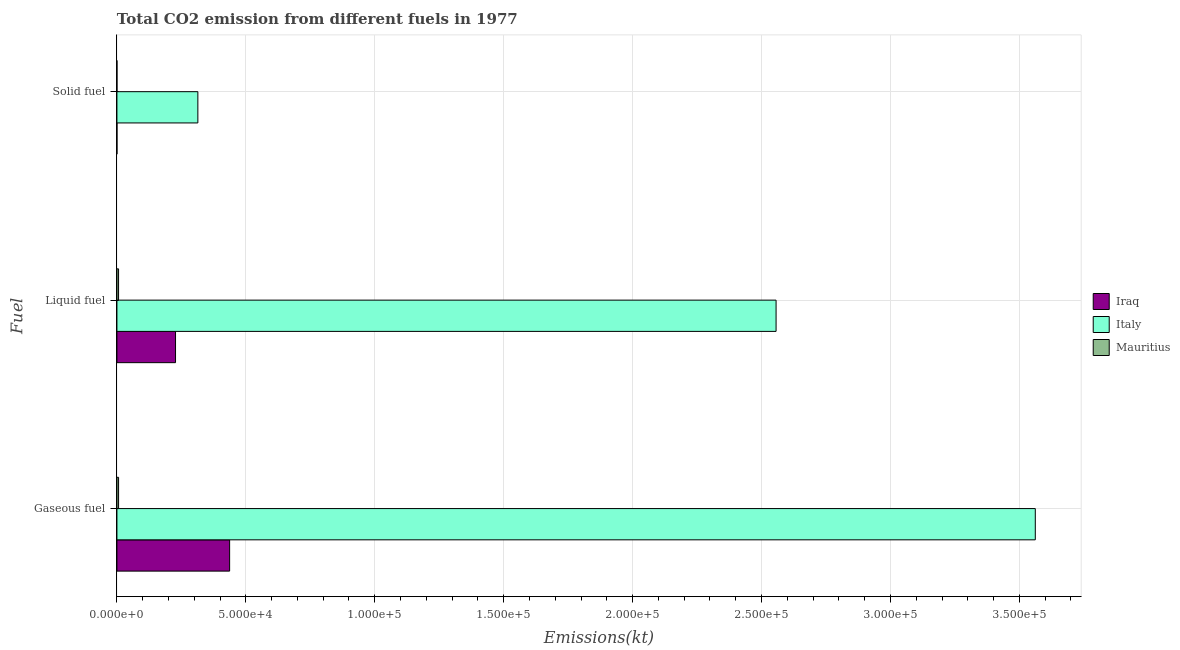Are the number of bars per tick equal to the number of legend labels?
Make the answer very short. Yes. What is the label of the 2nd group of bars from the top?
Give a very brief answer. Liquid fuel. What is the amount of co2 emissions from gaseous fuel in Italy?
Offer a terse response. 3.56e+05. Across all countries, what is the maximum amount of co2 emissions from gaseous fuel?
Ensure brevity in your answer.  3.56e+05. Across all countries, what is the minimum amount of co2 emissions from solid fuel?
Keep it short and to the point. 3.67. In which country was the amount of co2 emissions from solid fuel minimum?
Your answer should be very brief. Iraq. What is the total amount of co2 emissions from liquid fuel in the graph?
Provide a succinct answer. 2.79e+05. What is the difference between the amount of co2 emissions from liquid fuel in Mauritius and that in Italy?
Make the answer very short. -2.55e+05. What is the difference between the amount of co2 emissions from gaseous fuel in Iraq and the amount of co2 emissions from solid fuel in Mauritius?
Your response must be concise. 4.37e+04. What is the average amount of co2 emissions from liquid fuel per country?
Make the answer very short. 9.30e+04. What is the difference between the amount of co2 emissions from gaseous fuel and amount of co2 emissions from solid fuel in Mauritius?
Your answer should be compact. 638.06. In how many countries, is the amount of co2 emissions from liquid fuel greater than 130000 kt?
Make the answer very short. 1. What is the ratio of the amount of co2 emissions from liquid fuel in Italy to that in Iraq?
Provide a succinct answer. 11.25. Is the amount of co2 emissions from liquid fuel in Iraq less than that in Italy?
Offer a very short reply. Yes. Is the difference between the amount of co2 emissions from solid fuel in Italy and Mauritius greater than the difference between the amount of co2 emissions from gaseous fuel in Italy and Mauritius?
Your response must be concise. No. What is the difference between the highest and the second highest amount of co2 emissions from liquid fuel?
Offer a terse response. 2.33e+05. What is the difference between the highest and the lowest amount of co2 emissions from liquid fuel?
Give a very brief answer. 2.55e+05. Is the sum of the amount of co2 emissions from gaseous fuel in Mauritius and Iraq greater than the maximum amount of co2 emissions from liquid fuel across all countries?
Make the answer very short. No. What does the 3rd bar from the top in Solid fuel represents?
Make the answer very short. Iraq. What does the 3rd bar from the bottom in Gaseous fuel represents?
Offer a very short reply. Mauritius. Is it the case that in every country, the sum of the amount of co2 emissions from gaseous fuel and amount of co2 emissions from liquid fuel is greater than the amount of co2 emissions from solid fuel?
Your response must be concise. Yes. How many countries are there in the graph?
Offer a very short reply. 3. Are the values on the major ticks of X-axis written in scientific E-notation?
Offer a very short reply. Yes. Does the graph contain any zero values?
Keep it short and to the point. No. Does the graph contain grids?
Your answer should be compact. Yes. How many legend labels are there?
Offer a terse response. 3. What is the title of the graph?
Ensure brevity in your answer.  Total CO2 emission from different fuels in 1977. Does "Australia" appear as one of the legend labels in the graph?
Provide a succinct answer. No. What is the label or title of the X-axis?
Your response must be concise. Emissions(kt). What is the label or title of the Y-axis?
Make the answer very short. Fuel. What is the Emissions(kt) in Iraq in Gaseous fuel?
Ensure brevity in your answer.  4.37e+04. What is the Emissions(kt) of Italy in Gaseous fuel?
Provide a short and direct response. 3.56e+05. What is the Emissions(kt) of Mauritius in Gaseous fuel?
Keep it short and to the point. 641.73. What is the Emissions(kt) of Iraq in Liquid fuel?
Your answer should be very brief. 2.27e+04. What is the Emissions(kt) in Italy in Liquid fuel?
Keep it short and to the point. 2.56e+05. What is the Emissions(kt) in Mauritius in Liquid fuel?
Provide a succinct answer. 638.06. What is the Emissions(kt) in Iraq in Solid fuel?
Offer a very short reply. 3.67. What is the Emissions(kt) in Italy in Solid fuel?
Ensure brevity in your answer.  3.14e+04. What is the Emissions(kt) in Mauritius in Solid fuel?
Make the answer very short. 3.67. Across all Fuel, what is the maximum Emissions(kt) of Iraq?
Provide a succinct answer. 4.37e+04. Across all Fuel, what is the maximum Emissions(kt) of Italy?
Make the answer very short. 3.56e+05. Across all Fuel, what is the maximum Emissions(kt) of Mauritius?
Offer a very short reply. 641.73. Across all Fuel, what is the minimum Emissions(kt) in Iraq?
Your response must be concise. 3.67. Across all Fuel, what is the minimum Emissions(kt) of Italy?
Your answer should be compact. 3.14e+04. Across all Fuel, what is the minimum Emissions(kt) of Mauritius?
Keep it short and to the point. 3.67. What is the total Emissions(kt) of Iraq in the graph?
Provide a succinct answer. 6.64e+04. What is the total Emissions(kt) of Italy in the graph?
Provide a succinct answer. 6.43e+05. What is the total Emissions(kt) of Mauritius in the graph?
Your answer should be compact. 1283.45. What is the difference between the Emissions(kt) of Iraq in Gaseous fuel and that in Liquid fuel?
Provide a short and direct response. 2.10e+04. What is the difference between the Emissions(kt) of Italy in Gaseous fuel and that in Liquid fuel?
Your answer should be very brief. 1.01e+05. What is the difference between the Emissions(kt) of Mauritius in Gaseous fuel and that in Liquid fuel?
Your response must be concise. 3.67. What is the difference between the Emissions(kt) in Iraq in Gaseous fuel and that in Solid fuel?
Make the answer very short. 4.37e+04. What is the difference between the Emissions(kt) of Italy in Gaseous fuel and that in Solid fuel?
Your response must be concise. 3.25e+05. What is the difference between the Emissions(kt) of Mauritius in Gaseous fuel and that in Solid fuel?
Provide a short and direct response. 638.06. What is the difference between the Emissions(kt) in Iraq in Liquid fuel and that in Solid fuel?
Make the answer very short. 2.27e+04. What is the difference between the Emissions(kt) in Italy in Liquid fuel and that in Solid fuel?
Your answer should be compact. 2.24e+05. What is the difference between the Emissions(kt) in Mauritius in Liquid fuel and that in Solid fuel?
Ensure brevity in your answer.  634.39. What is the difference between the Emissions(kt) in Iraq in Gaseous fuel and the Emissions(kt) in Italy in Liquid fuel?
Offer a terse response. -2.12e+05. What is the difference between the Emissions(kt) in Iraq in Gaseous fuel and the Emissions(kt) in Mauritius in Liquid fuel?
Keep it short and to the point. 4.31e+04. What is the difference between the Emissions(kt) in Italy in Gaseous fuel and the Emissions(kt) in Mauritius in Liquid fuel?
Ensure brevity in your answer.  3.56e+05. What is the difference between the Emissions(kt) of Iraq in Gaseous fuel and the Emissions(kt) of Italy in Solid fuel?
Provide a short and direct response. 1.23e+04. What is the difference between the Emissions(kt) of Iraq in Gaseous fuel and the Emissions(kt) of Mauritius in Solid fuel?
Provide a short and direct response. 4.37e+04. What is the difference between the Emissions(kt) in Italy in Gaseous fuel and the Emissions(kt) in Mauritius in Solid fuel?
Your response must be concise. 3.56e+05. What is the difference between the Emissions(kt) in Iraq in Liquid fuel and the Emissions(kt) in Italy in Solid fuel?
Offer a very short reply. -8665.12. What is the difference between the Emissions(kt) in Iraq in Liquid fuel and the Emissions(kt) in Mauritius in Solid fuel?
Provide a short and direct response. 2.27e+04. What is the difference between the Emissions(kt) of Italy in Liquid fuel and the Emissions(kt) of Mauritius in Solid fuel?
Keep it short and to the point. 2.56e+05. What is the average Emissions(kt) of Iraq per Fuel?
Provide a short and direct response. 2.21e+04. What is the average Emissions(kt) in Italy per Fuel?
Your answer should be very brief. 2.14e+05. What is the average Emissions(kt) of Mauritius per Fuel?
Provide a succinct answer. 427.82. What is the difference between the Emissions(kt) in Iraq and Emissions(kt) in Italy in Gaseous fuel?
Offer a very short reply. -3.12e+05. What is the difference between the Emissions(kt) of Iraq and Emissions(kt) of Mauritius in Gaseous fuel?
Keep it short and to the point. 4.31e+04. What is the difference between the Emissions(kt) in Italy and Emissions(kt) in Mauritius in Gaseous fuel?
Ensure brevity in your answer.  3.56e+05. What is the difference between the Emissions(kt) of Iraq and Emissions(kt) of Italy in Liquid fuel?
Provide a succinct answer. -2.33e+05. What is the difference between the Emissions(kt) of Iraq and Emissions(kt) of Mauritius in Liquid fuel?
Your response must be concise. 2.21e+04. What is the difference between the Emissions(kt) in Italy and Emissions(kt) in Mauritius in Liquid fuel?
Your answer should be compact. 2.55e+05. What is the difference between the Emissions(kt) in Iraq and Emissions(kt) in Italy in Solid fuel?
Your response must be concise. -3.14e+04. What is the difference between the Emissions(kt) of Italy and Emissions(kt) of Mauritius in Solid fuel?
Provide a succinct answer. 3.14e+04. What is the ratio of the Emissions(kt) in Iraq in Gaseous fuel to that in Liquid fuel?
Your response must be concise. 1.92. What is the ratio of the Emissions(kt) of Italy in Gaseous fuel to that in Liquid fuel?
Your answer should be very brief. 1.39. What is the ratio of the Emissions(kt) of Mauritius in Gaseous fuel to that in Liquid fuel?
Your answer should be very brief. 1.01. What is the ratio of the Emissions(kt) in Iraq in Gaseous fuel to that in Solid fuel?
Your answer should be very brief. 1.19e+04. What is the ratio of the Emissions(kt) of Italy in Gaseous fuel to that in Solid fuel?
Make the answer very short. 11.35. What is the ratio of the Emissions(kt) in Mauritius in Gaseous fuel to that in Solid fuel?
Offer a terse response. 175. What is the ratio of the Emissions(kt) of Iraq in Liquid fuel to that in Solid fuel?
Give a very brief answer. 6198. What is the ratio of the Emissions(kt) of Italy in Liquid fuel to that in Solid fuel?
Your answer should be compact. 8.14. What is the ratio of the Emissions(kt) in Mauritius in Liquid fuel to that in Solid fuel?
Provide a succinct answer. 174. What is the difference between the highest and the second highest Emissions(kt) in Iraq?
Make the answer very short. 2.10e+04. What is the difference between the highest and the second highest Emissions(kt) in Italy?
Provide a short and direct response. 1.01e+05. What is the difference between the highest and the second highest Emissions(kt) of Mauritius?
Provide a succinct answer. 3.67. What is the difference between the highest and the lowest Emissions(kt) of Iraq?
Offer a very short reply. 4.37e+04. What is the difference between the highest and the lowest Emissions(kt) in Italy?
Your answer should be very brief. 3.25e+05. What is the difference between the highest and the lowest Emissions(kt) in Mauritius?
Provide a short and direct response. 638.06. 